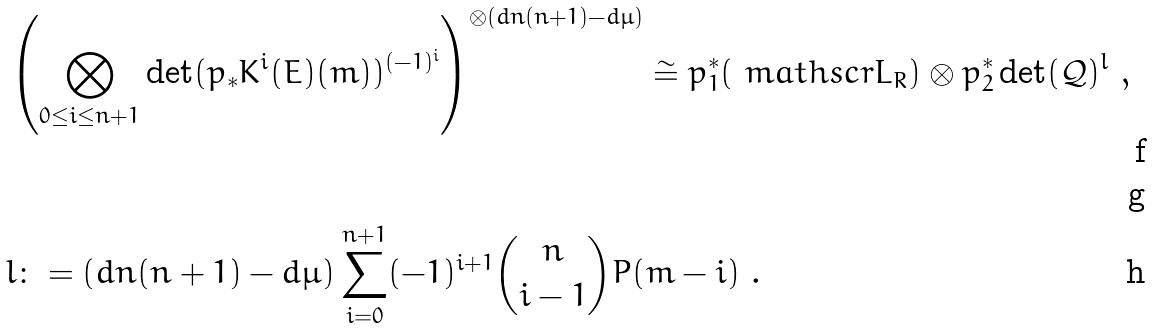<formula> <loc_0><loc_0><loc_500><loc_500>& \left ( \bigotimes _ { 0 \leq i \leq n + 1 } \det ( p _ { * } K ^ { i } ( E ) ( m ) ) ^ { ( - 1 ) ^ { i } } \right ) ^ { \otimes ( d n ( n + 1 ) - d \mu ) } \cong p _ { 1 } ^ { * } ( \ m a t h s c r { L } _ { R } ) \otimes p _ { 2 } ^ { * } \det ( \mathcal { Q } ) ^ { l } \ , \\ \ \\ & l \colon = ( d n ( n + 1 ) - d \mu ) \sum _ { i = 0 } ^ { n + 1 } ( - 1 ) ^ { i + 1 } \binom { n } { i - 1 } P ( m - i ) \ .</formula> 